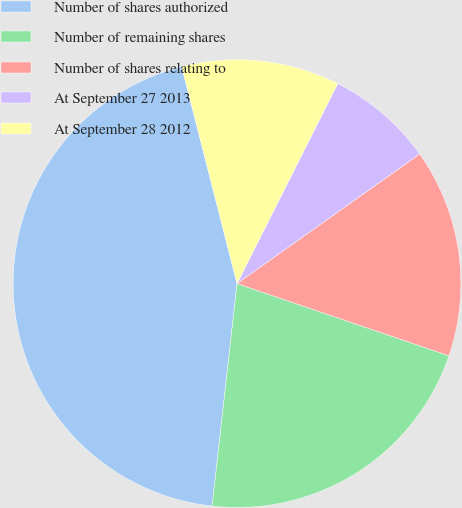Convert chart to OTSL. <chart><loc_0><loc_0><loc_500><loc_500><pie_chart><fcel>Number of shares authorized<fcel>Number of remaining shares<fcel>Number of shares relating to<fcel>At September 27 2013<fcel>At September 28 2012<nl><fcel>44.25%<fcel>21.55%<fcel>15.05%<fcel>7.75%<fcel>11.4%<nl></chart> 